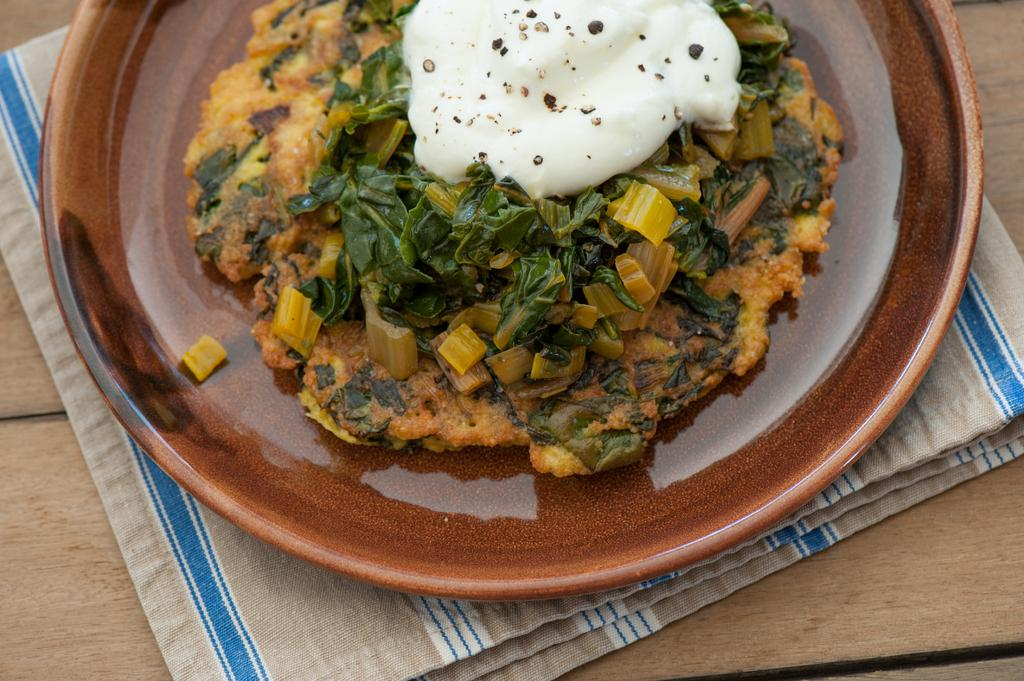What is present on the wooden surface in the image? There is a plate in the image, which is on a wooden surface. What else can be seen on the wooden surface? There is a cloth on the wooden surface. What is on the plate in the image? There is food on the plate. What type of needle is being played on the wooden surface in the image? There is no needle or guitar present in the image; it only features a plate, food, and a cloth on a wooden surface. How does the cloth help in washing the food on the plate? The cloth is not used for washing the food in the image; it is simply placed on the wooden surface. 